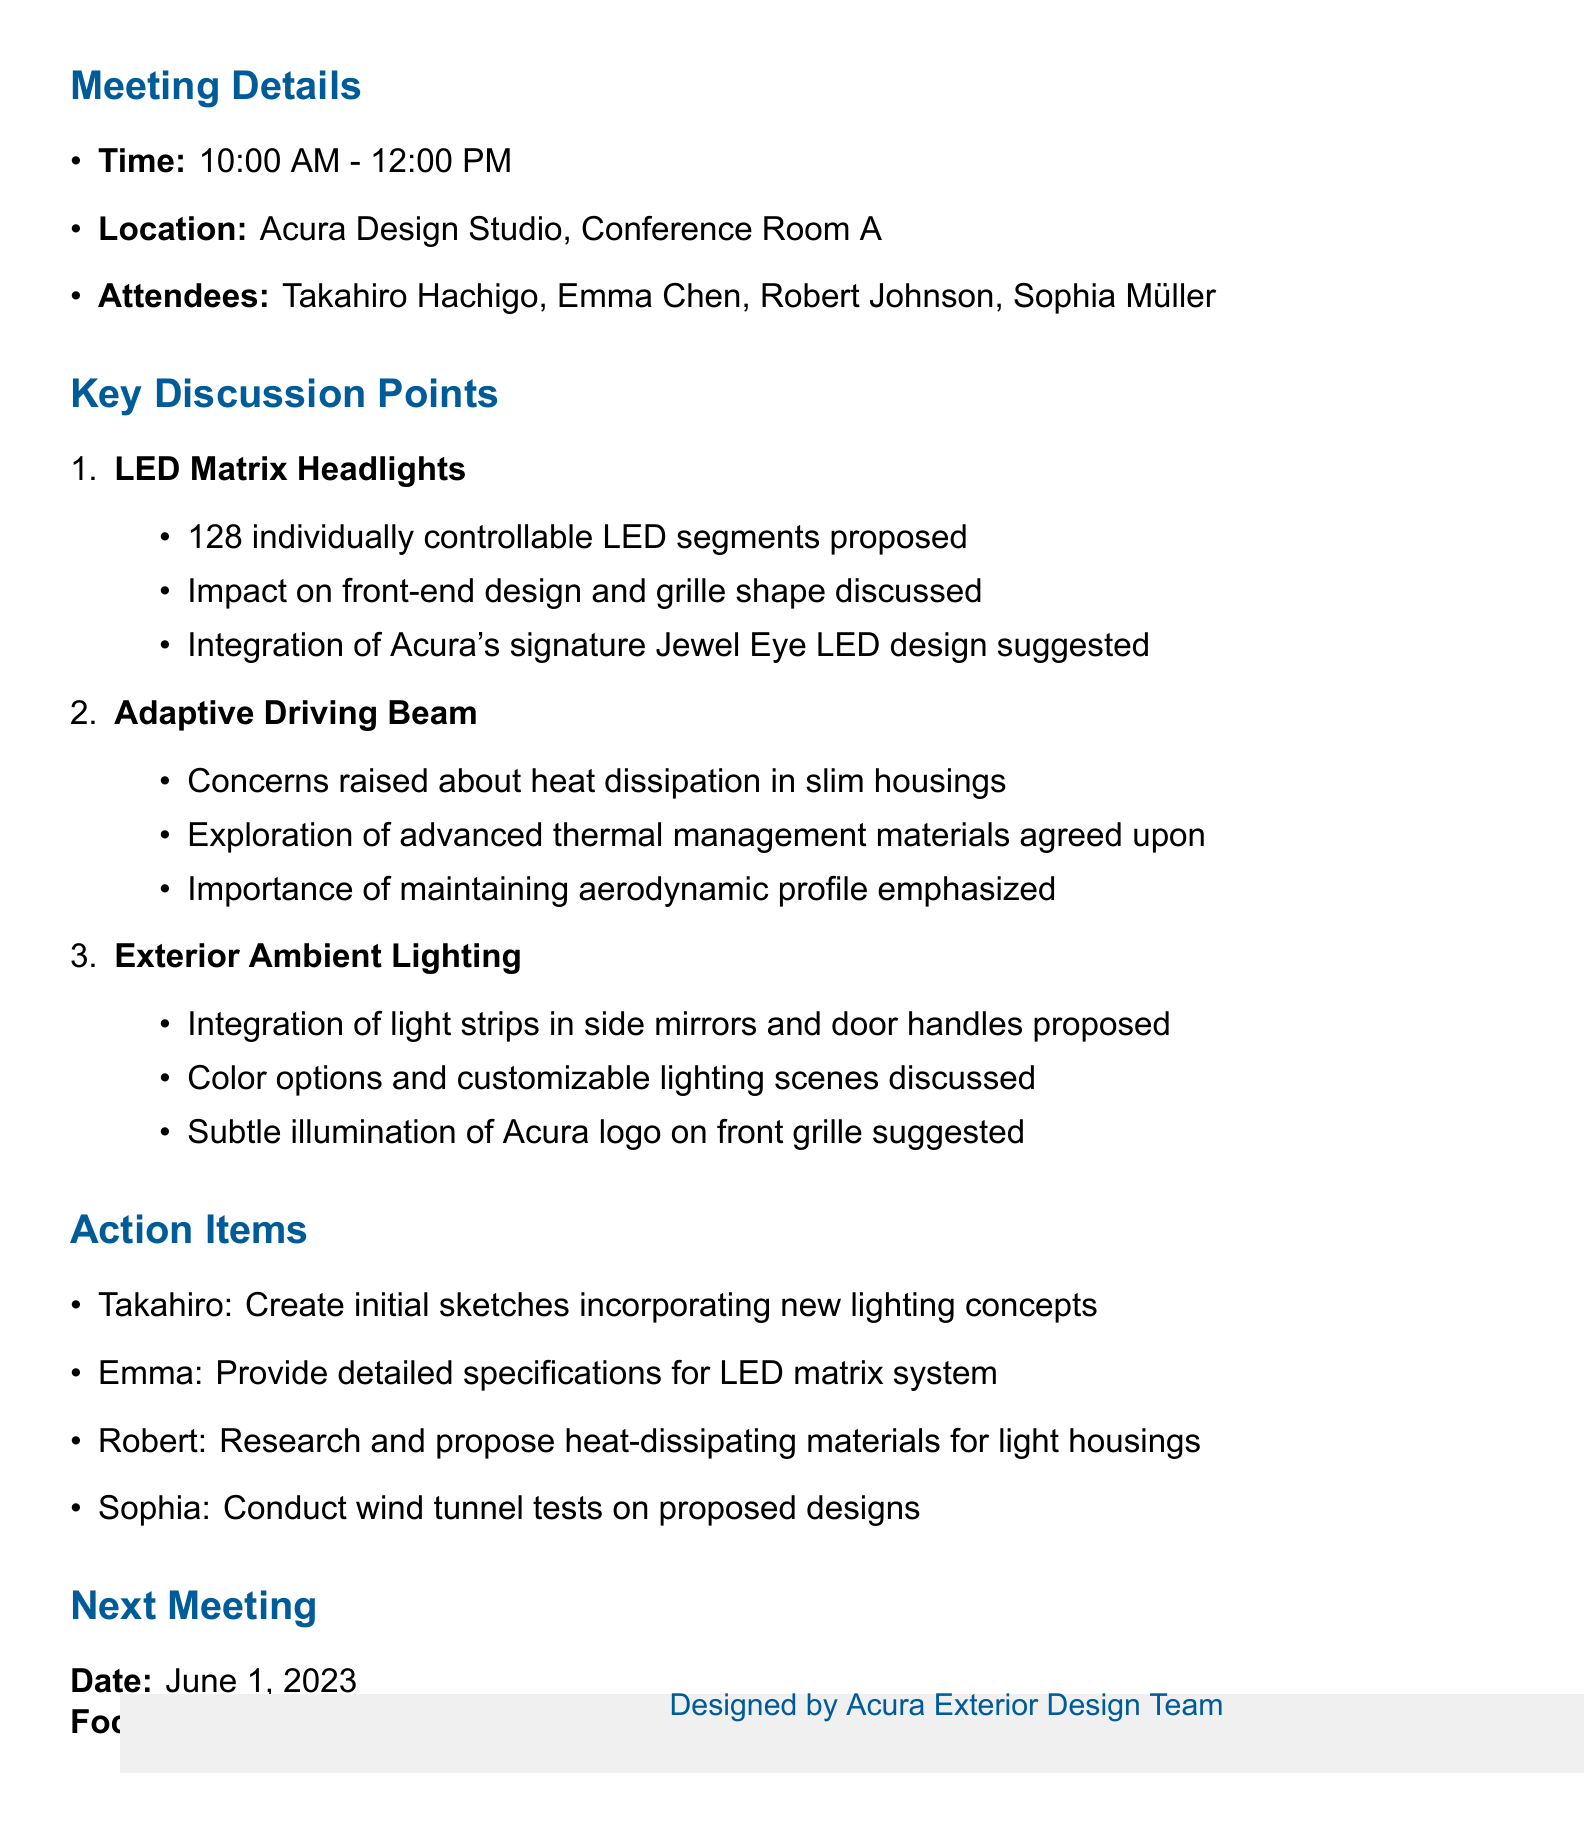What is the date of the meeting? The meeting took place on May 15, 2023, as mentioned in the meeting details.
Answer: May 15, 2023 Who is the Lead Exterior Designer? The Lead Exterior Designer is listed as Takahiro Hachigo in the attendee section.
Answer: Takahiro Hachigo What technology was proposed for integration regarding the headlights? The discussion included LED matrix headlights as a key agenda item.
Answer: LED matrix headlights How many LED segments were proposed for the matrix headlights? The notes specify a proposal of 128 individually controllable LED segments for the headlights.
Answer: 128 What is the focus of the next meeting? The next meeting's focus is to review initial design sketches and engineering feasibility reports, as stated in the document.
Answer: Review of initial design sketches and engineering feasibility reports Which attendee raised concerns about heat dissipation? Robert Johnson is the attendee who raised concerns about heat dissipation in slim housings.
Answer: Robert Johnson What was suggested for the integration of ambient lighting? The proposal included the integration of light strips in side mirrors and door handles, among other ideas.
Answer: Light strips in side mirrors and door handles What task was assigned to Emma Chen? Emma was assigned to provide detailed specifications for the LED matrix system.
Answer: Provide detailed specifications for LED matrix system What kind of materials was Robert tasked to research? Robert was tasked with researching and proposing heat-dissipating materials for light housings.
Answer: Heat-dissipating materials 